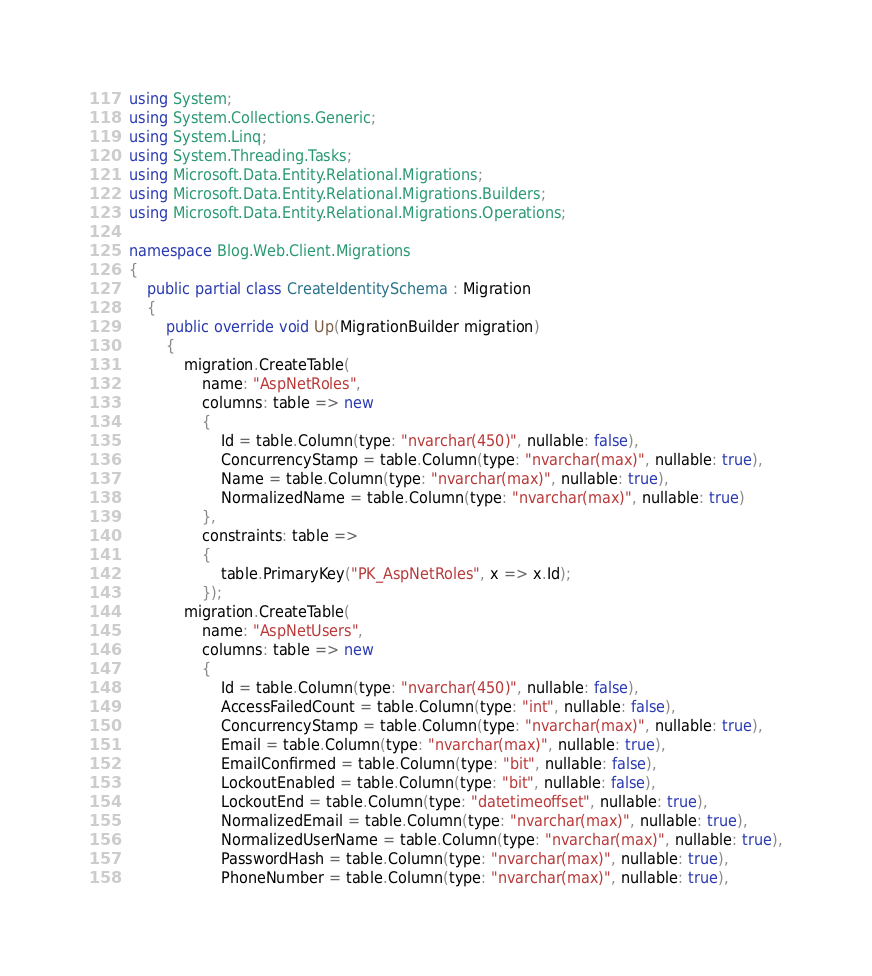<code> <loc_0><loc_0><loc_500><loc_500><_C#_>using System;
using System.Collections.Generic;
using System.Linq;
using System.Threading.Tasks;
using Microsoft.Data.Entity.Relational.Migrations;
using Microsoft.Data.Entity.Relational.Migrations.Builders;
using Microsoft.Data.Entity.Relational.Migrations.Operations;

namespace Blog.Web.Client.Migrations
{
    public partial class CreateIdentitySchema : Migration
    {
        public override void Up(MigrationBuilder migration)
        {
            migration.CreateTable(
                name: "AspNetRoles",
                columns: table => new
                {
                    Id = table.Column(type: "nvarchar(450)", nullable: false),
                    ConcurrencyStamp = table.Column(type: "nvarchar(max)", nullable: true),
                    Name = table.Column(type: "nvarchar(max)", nullable: true),
                    NormalizedName = table.Column(type: "nvarchar(max)", nullable: true)
                },
                constraints: table =>
                {
                    table.PrimaryKey("PK_AspNetRoles", x => x.Id);
                });
            migration.CreateTable(
                name: "AspNetUsers",
                columns: table => new
                {
                    Id = table.Column(type: "nvarchar(450)", nullable: false),
                    AccessFailedCount = table.Column(type: "int", nullable: false),
                    ConcurrencyStamp = table.Column(type: "nvarchar(max)", nullable: true),
                    Email = table.Column(type: "nvarchar(max)", nullable: true),
                    EmailConfirmed = table.Column(type: "bit", nullable: false),
                    LockoutEnabled = table.Column(type: "bit", nullable: false),
                    LockoutEnd = table.Column(type: "datetimeoffset", nullable: true),
                    NormalizedEmail = table.Column(type: "nvarchar(max)", nullable: true),
                    NormalizedUserName = table.Column(type: "nvarchar(max)", nullable: true),
                    PasswordHash = table.Column(type: "nvarchar(max)", nullable: true),
                    PhoneNumber = table.Column(type: "nvarchar(max)", nullable: true),</code> 